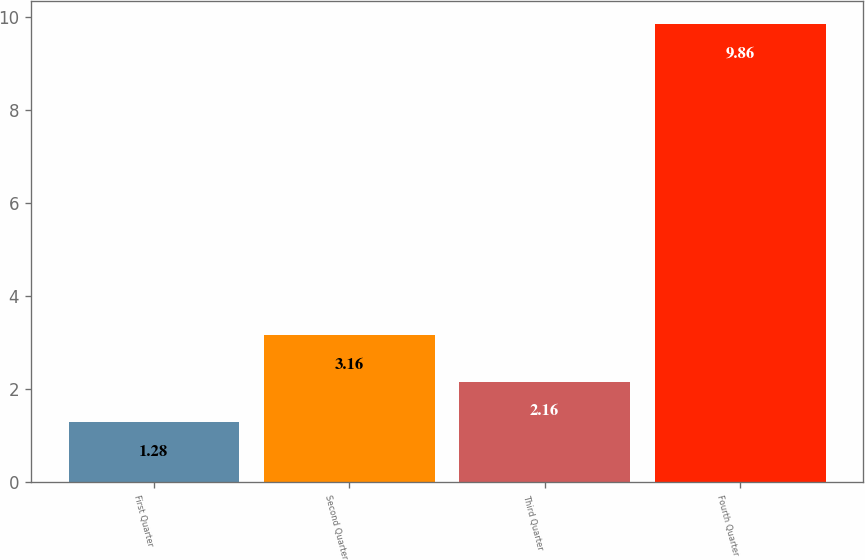<chart> <loc_0><loc_0><loc_500><loc_500><bar_chart><fcel>First Quarter<fcel>Second Quarter<fcel>Third Quarter<fcel>Fourth Quarter<nl><fcel>1.28<fcel>3.16<fcel>2.16<fcel>9.86<nl></chart> 